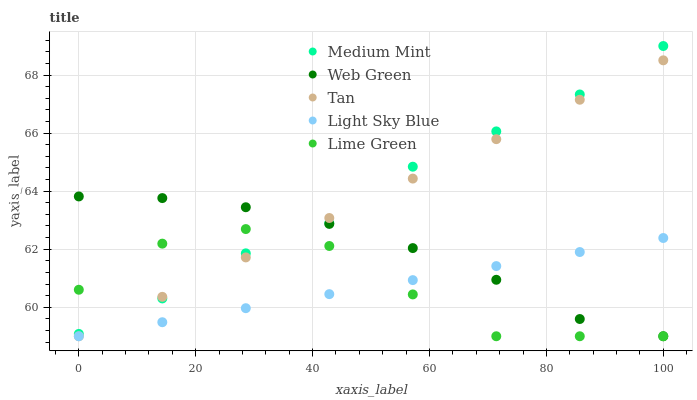Does Light Sky Blue have the minimum area under the curve?
Answer yes or no. Yes. Does Medium Mint have the maximum area under the curve?
Answer yes or no. Yes. Does Tan have the minimum area under the curve?
Answer yes or no. No. Does Tan have the maximum area under the curve?
Answer yes or no. No. Is Light Sky Blue the smoothest?
Answer yes or no. Yes. Is Lime Green the roughest?
Answer yes or no. Yes. Is Tan the smoothest?
Answer yes or no. No. Is Tan the roughest?
Answer yes or no. No. Does Tan have the lowest value?
Answer yes or no. Yes. Does Medium Mint have the highest value?
Answer yes or no. Yes. Does Tan have the highest value?
Answer yes or no. No. Is Light Sky Blue less than Medium Mint?
Answer yes or no. Yes. Is Medium Mint greater than Light Sky Blue?
Answer yes or no. Yes. Does Lime Green intersect Medium Mint?
Answer yes or no. Yes. Is Lime Green less than Medium Mint?
Answer yes or no. No. Is Lime Green greater than Medium Mint?
Answer yes or no. No. Does Light Sky Blue intersect Medium Mint?
Answer yes or no. No. 